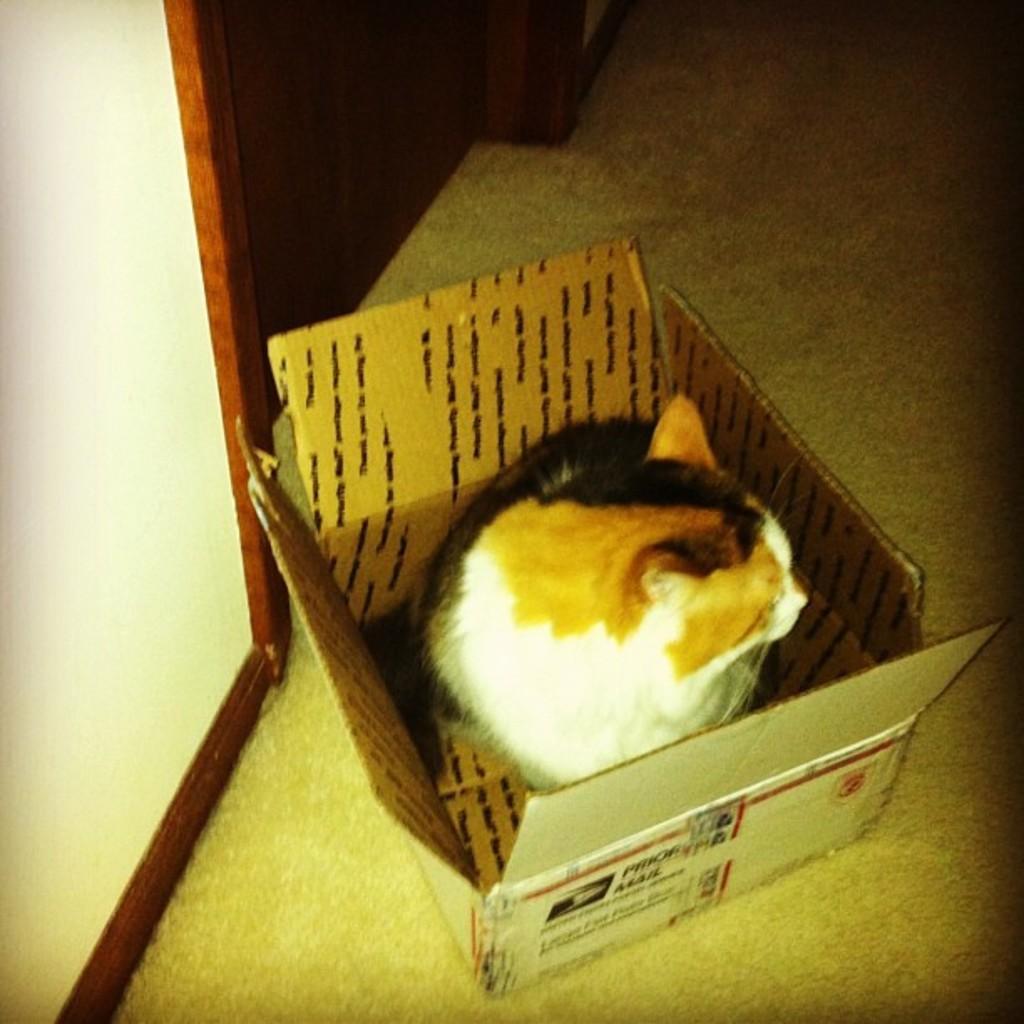In one or two sentences, can you explain what this image depicts? This is a zoomed in picture which is clicked inside. In the foreground we can see a cat seems to be sitting in the box and the box is placed on the ground. On the left corner there is a white color door. In the background we can see the ground. 